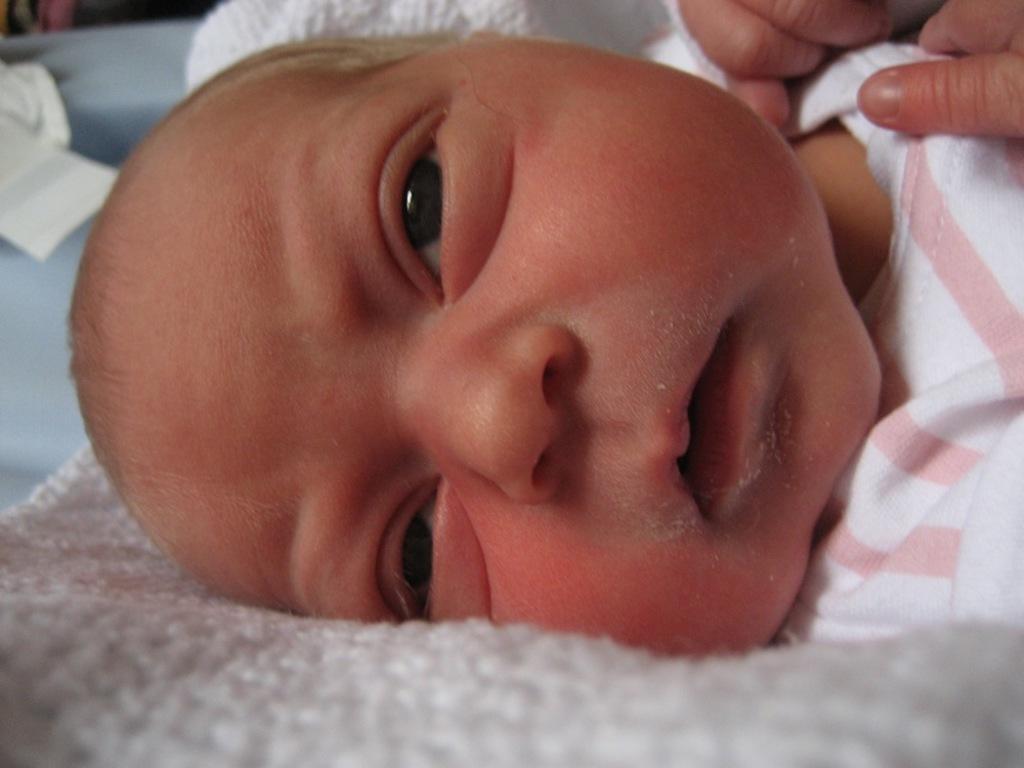Could you give a brief overview of what you see in this image? This is a child wearing clothes. 